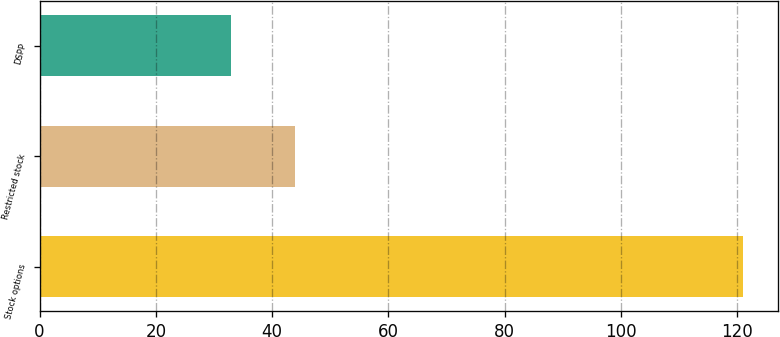Convert chart to OTSL. <chart><loc_0><loc_0><loc_500><loc_500><bar_chart><fcel>Stock options<fcel>Restricted stock<fcel>DSPP<nl><fcel>121<fcel>44<fcel>33<nl></chart> 